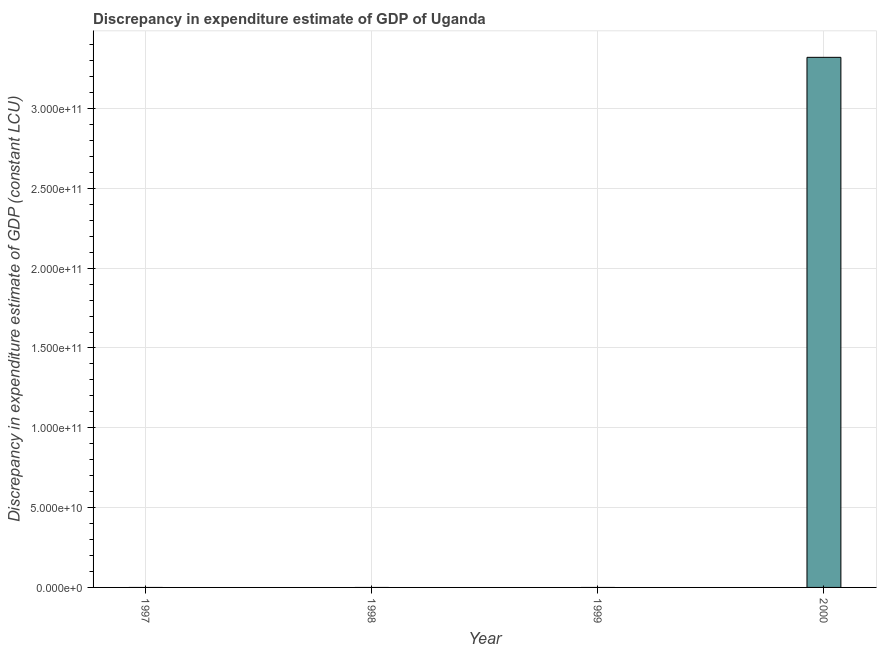What is the title of the graph?
Provide a short and direct response. Discrepancy in expenditure estimate of GDP of Uganda. What is the label or title of the X-axis?
Offer a terse response. Year. What is the label or title of the Y-axis?
Your response must be concise. Discrepancy in expenditure estimate of GDP (constant LCU). What is the discrepancy in expenditure estimate of gdp in 1998?
Offer a terse response. 0. Across all years, what is the maximum discrepancy in expenditure estimate of gdp?
Provide a short and direct response. 3.32e+11. What is the sum of the discrepancy in expenditure estimate of gdp?
Provide a succinct answer. 3.32e+11. What is the average discrepancy in expenditure estimate of gdp per year?
Your response must be concise. 8.30e+1. In how many years, is the discrepancy in expenditure estimate of gdp greater than 330000000000 LCU?
Offer a very short reply. 1. What is the difference between the highest and the lowest discrepancy in expenditure estimate of gdp?
Your answer should be very brief. 3.32e+11. In how many years, is the discrepancy in expenditure estimate of gdp greater than the average discrepancy in expenditure estimate of gdp taken over all years?
Give a very brief answer. 1. How many years are there in the graph?
Your answer should be very brief. 4. What is the Discrepancy in expenditure estimate of GDP (constant LCU) of 1999?
Your response must be concise. 0. What is the Discrepancy in expenditure estimate of GDP (constant LCU) of 2000?
Provide a short and direct response. 3.32e+11. 